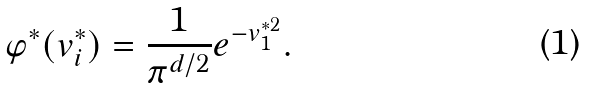Convert formula to latex. <formula><loc_0><loc_0><loc_500><loc_500>\varphi ^ { \ast } ( { v } _ { i } ^ { \ast } ) = \frac { 1 } { \pi ^ { d / 2 } } e ^ { - v _ { 1 } ^ { \ast 2 } } .</formula> 